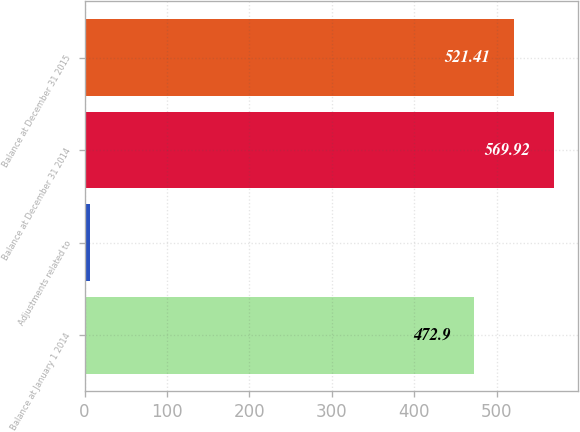<chart> <loc_0><loc_0><loc_500><loc_500><bar_chart><fcel>Balance at January 1 2014<fcel>Adjustments related to<fcel>Balance at December 31 2014<fcel>Balance at December 31 2015<nl><fcel>472.9<fcel>6.5<fcel>569.92<fcel>521.41<nl></chart> 